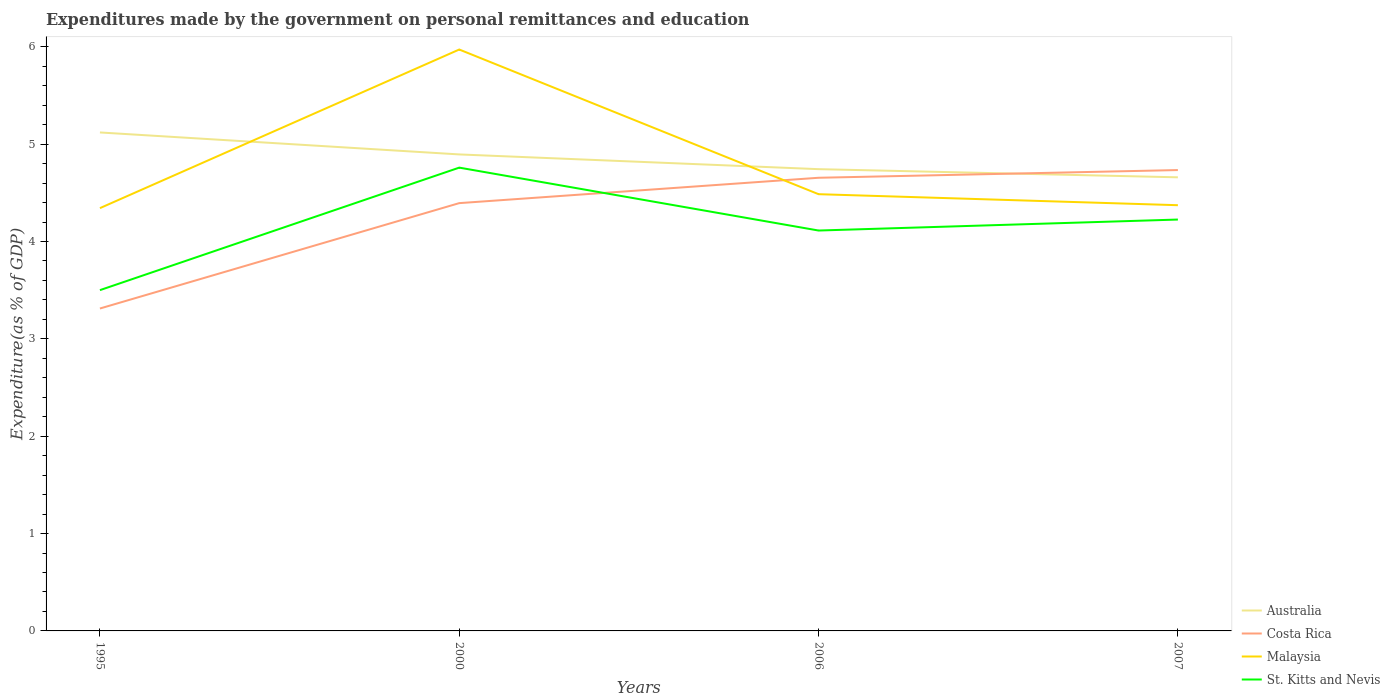Across all years, what is the maximum expenditures made by the government on personal remittances and education in St. Kitts and Nevis?
Keep it short and to the point. 3.5. What is the total expenditures made by the government on personal remittances and education in Australia in the graph?
Make the answer very short. 0.24. What is the difference between the highest and the second highest expenditures made by the government on personal remittances and education in Costa Rica?
Give a very brief answer. 1.42. How many lines are there?
Offer a terse response. 4. How many years are there in the graph?
Make the answer very short. 4. Are the values on the major ticks of Y-axis written in scientific E-notation?
Provide a short and direct response. No. Does the graph contain any zero values?
Provide a succinct answer. No. Does the graph contain grids?
Provide a short and direct response. No. How are the legend labels stacked?
Ensure brevity in your answer.  Vertical. What is the title of the graph?
Your answer should be compact. Expenditures made by the government on personal remittances and education. Does "Bahamas" appear as one of the legend labels in the graph?
Your answer should be compact. No. What is the label or title of the X-axis?
Your answer should be very brief. Years. What is the label or title of the Y-axis?
Make the answer very short. Expenditure(as % of GDP). What is the Expenditure(as % of GDP) of Australia in 1995?
Keep it short and to the point. 5.12. What is the Expenditure(as % of GDP) in Costa Rica in 1995?
Offer a terse response. 3.31. What is the Expenditure(as % of GDP) in Malaysia in 1995?
Offer a very short reply. 4.34. What is the Expenditure(as % of GDP) in St. Kitts and Nevis in 1995?
Keep it short and to the point. 3.5. What is the Expenditure(as % of GDP) of Australia in 2000?
Ensure brevity in your answer.  4.89. What is the Expenditure(as % of GDP) of Costa Rica in 2000?
Provide a short and direct response. 4.39. What is the Expenditure(as % of GDP) of Malaysia in 2000?
Make the answer very short. 5.97. What is the Expenditure(as % of GDP) in St. Kitts and Nevis in 2000?
Your answer should be compact. 4.76. What is the Expenditure(as % of GDP) in Australia in 2006?
Keep it short and to the point. 4.74. What is the Expenditure(as % of GDP) of Costa Rica in 2006?
Provide a succinct answer. 4.65. What is the Expenditure(as % of GDP) in Malaysia in 2006?
Your response must be concise. 4.49. What is the Expenditure(as % of GDP) in St. Kitts and Nevis in 2006?
Provide a short and direct response. 4.11. What is the Expenditure(as % of GDP) of Australia in 2007?
Your response must be concise. 4.66. What is the Expenditure(as % of GDP) of Costa Rica in 2007?
Your answer should be compact. 4.73. What is the Expenditure(as % of GDP) in Malaysia in 2007?
Provide a succinct answer. 4.37. What is the Expenditure(as % of GDP) of St. Kitts and Nevis in 2007?
Offer a terse response. 4.23. Across all years, what is the maximum Expenditure(as % of GDP) in Australia?
Your response must be concise. 5.12. Across all years, what is the maximum Expenditure(as % of GDP) of Costa Rica?
Your answer should be compact. 4.73. Across all years, what is the maximum Expenditure(as % of GDP) in Malaysia?
Make the answer very short. 5.97. Across all years, what is the maximum Expenditure(as % of GDP) in St. Kitts and Nevis?
Your answer should be very brief. 4.76. Across all years, what is the minimum Expenditure(as % of GDP) in Australia?
Provide a succinct answer. 4.66. Across all years, what is the minimum Expenditure(as % of GDP) of Costa Rica?
Your answer should be very brief. 3.31. Across all years, what is the minimum Expenditure(as % of GDP) in Malaysia?
Your response must be concise. 4.34. Across all years, what is the minimum Expenditure(as % of GDP) of St. Kitts and Nevis?
Your answer should be very brief. 3.5. What is the total Expenditure(as % of GDP) in Australia in the graph?
Your answer should be compact. 19.42. What is the total Expenditure(as % of GDP) of Costa Rica in the graph?
Make the answer very short. 17.09. What is the total Expenditure(as % of GDP) of Malaysia in the graph?
Ensure brevity in your answer.  19.17. What is the total Expenditure(as % of GDP) of St. Kitts and Nevis in the graph?
Ensure brevity in your answer.  16.6. What is the difference between the Expenditure(as % of GDP) in Australia in 1995 and that in 2000?
Offer a very short reply. 0.23. What is the difference between the Expenditure(as % of GDP) of Costa Rica in 1995 and that in 2000?
Give a very brief answer. -1.08. What is the difference between the Expenditure(as % of GDP) in Malaysia in 1995 and that in 2000?
Ensure brevity in your answer.  -1.63. What is the difference between the Expenditure(as % of GDP) in St. Kitts and Nevis in 1995 and that in 2000?
Ensure brevity in your answer.  -1.26. What is the difference between the Expenditure(as % of GDP) in Australia in 1995 and that in 2006?
Provide a succinct answer. 0.38. What is the difference between the Expenditure(as % of GDP) of Costa Rica in 1995 and that in 2006?
Ensure brevity in your answer.  -1.34. What is the difference between the Expenditure(as % of GDP) in Malaysia in 1995 and that in 2006?
Provide a succinct answer. -0.14. What is the difference between the Expenditure(as % of GDP) in St. Kitts and Nevis in 1995 and that in 2006?
Your response must be concise. -0.61. What is the difference between the Expenditure(as % of GDP) in Australia in 1995 and that in 2007?
Offer a terse response. 0.46. What is the difference between the Expenditure(as % of GDP) in Costa Rica in 1995 and that in 2007?
Offer a very short reply. -1.42. What is the difference between the Expenditure(as % of GDP) in Malaysia in 1995 and that in 2007?
Your response must be concise. -0.03. What is the difference between the Expenditure(as % of GDP) in St. Kitts and Nevis in 1995 and that in 2007?
Keep it short and to the point. -0.72. What is the difference between the Expenditure(as % of GDP) in Australia in 2000 and that in 2006?
Provide a succinct answer. 0.15. What is the difference between the Expenditure(as % of GDP) of Costa Rica in 2000 and that in 2006?
Give a very brief answer. -0.26. What is the difference between the Expenditure(as % of GDP) of Malaysia in 2000 and that in 2006?
Offer a terse response. 1.49. What is the difference between the Expenditure(as % of GDP) of St. Kitts and Nevis in 2000 and that in 2006?
Your answer should be very brief. 0.65. What is the difference between the Expenditure(as % of GDP) of Australia in 2000 and that in 2007?
Ensure brevity in your answer.  0.24. What is the difference between the Expenditure(as % of GDP) of Costa Rica in 2000 and that in 2007?
Make the answer very short. -0.34. What is the difference between the Expenditure(as % of GDP) in Malaysia in 2000 and that in 2007?
Offer a terse response. 1.6. What is the difference between the Expenditure(as % of GDP) of St. Kitts and Nevis in 2000 and that in 2007?
Ensure brevity in your answer.  0.53. What is the difference between the Expenditure(as % of GDP) of Australia in 2006 and that in 2007?
Provide a succinct answer. 0.08. What is the difference between the Expenditure(as % of GDP) in Costa Rica in 2006 and that in 2007?
Make the answer very short. -0.08. What is the difference between the Expenditure(as % of GDP) of Malaysia in 2006 and that in 2007?
Your answer should be very brief. 0.11. What is the difference between the Expenditure(as % of GDP) in St. Kitts and Nevis in 2006 and that in 2007?
Ensure brevity in your answer.  -0.11. What is the difference between the Expenditure(as % of GDP) in Australia in 1995 and the Expenditure(as % of GDP) in Costa Rica in 2000?
Your answer should be compact. 0.73. What is the difference between the Expenditure(as % of GDP) in Australia in 1995 and the Expenditure(as % of GDP) in Malaysia in 2000?
Keep it short and to the point. -0.85. What is the difference between the Expenditure(as % of GDP) in Australia in 1995 and the Expenditure(as % of GDP) in St. Kitts and Nevis in 2000?
Offer a terse response. 0.36. What is the difference between the Expenditure(as % of GDP) of Costa Rica in 1995 and the Expenditure(as % of GDP) of Malaysia in 2000?
Offer a terse response. -2.66. What is the difference between the Expenditure(as % of GDP) in Costa Rica in 1995 and the Expenditure(as % of GDP) in St. Kitts and Nevis in 2000?
Provide a succinct answer. -1.45. What is the difference between the Expenditure(as % of GDP) of Malaysia in 1995 and the Expenditure(as % of GDP) of St. Kitts and Nevis in 2000?
Your answer should be very brief. -0.42. What is the difference between the Expenditure(as % of GDP) of Australia in 1995 and the Expenditure(as % of GDP) of Costa Rica in 2006?
Your answer should be compact. 0.47. What is the difference between the Expenditure(as % of GDP) of Australia in 1995 and the Expenditure(as % of GDP) of Malaysia in 2006?
Provide a short and direct response. 0.63. What is the difference between the Expenditure(as % of GDP) in Australia in 1995 and the Expenditure(as % of GDP) in St. Kitts and Nevis in 2006?
Give a very brief answer. 1.01. What is the difference between the Expenditure(as % of GDP) of Costa Rica in 1995 and the Expenditure(as % of GDP) of Malaysia in 2006?
Your response must be concise. -1.17. What is the difference between the Expenditure(as % of GDP) of Costa Rica in 1995 and the Expenditure(as % of GDP) of St. Kitts and Nevis in 2006?
Give a very brief answer. -0.8. What is the difference between the Expenditure(as % of GDP) in Malaysia in 1995 and the Expenditure(as % of GDP) in St. Kitts and Nevis in 2006?
Provide a succinct answer. 0.23. What is the difference between the Expenditure(as % of GDP) of Australia in 1995 and the Expenditure(as % of GDP) of Costa Rica in 2007?
Provide a short and direct response. 0.39. What is the difference between the Expenditure(as % of GDP) of Australia in 1995 and the Expenditure(as % of GDP) of Malaysia in 2007?
Offer a terse response. 0.75. What is the difference between the Expenditure(as % of GDP) of Australia in 1995 and the Expenditure(as % of GDP) of St. Kitts and Nevis in 2007?
Offer a terse response. 0.89. What is the difference between the Expenditure(as % of GDP) of Costa Rica in 1995 and the Expenditure(as % of GDP) of Malaysia in 2007?
Make the answer very short. -1.06. What is the difference between the Expenditure(as % of GDP) of Costa Rica in 1995 and the Expenditure(as % of GDP) of St. Kitts and Nevis in 2007?
Make the answer very short. -0.91. What is the difference between the Expenditure(as % of GDP) in Malaysia in 1995 and the Expenditure(as % of GDP) in St. Kitts and Nevis in 2007?
Give a very brief answer. 0.12. What is the difference between the Expenditure(as % of GDP) of Australia in 2000 and the Expenditure(as % of GDP) of Costa Rica in 2006?
Your response must be concise. 0.24. What is the difference between the Expenditure(as % of GDP) in Australia in 2000 and the Expenditure(as % of GDP) in Malaysia in 2006?
Offer a very short reply. 0.41. What is the difference between the Expenditure(as % of GDP) in Australia in 2000 and the Expenditure(as % of GDP) in St. Kitts and Nevis in 2006?
Make the answer very short. 0.78. What is the difference between the Expenditure(as % of GDP) of Costa Rica in 2000 and the Expenditure(as % of GDP) of Malaysia in 2006?
Offer a terse response. -0.09. What is the difference between the Expenditure(as % of GDP) in Costa Rica in 2000 and the Expenditure(as % of GDP) in St. Kitts and Nevis in 2006?
Keep it short and to the point. 0.28. What is the difference between the Expenditure(as % of GDP) in Malaysia in 2000 and the Expenditure(as % of GDP) in St. Kitts and Nevis in 2006?
Ensure brevity in your answer.  1.86. What is the difference between the Expenditure(as % of GDP) of Australia in 2000 and the Expenditure(as % of GDP) of Costa Rica in 2007?
Keep it short and to the point. 0.16. What is the difference between the Expenditure(as % of GDP) of Australia in 2000 and the Expenditure(as % of GDP) of Malaysia in 2007?
Provide a short and direct response. 0.52. What is the difference between the Expenditure(as % of GDP) of Australia in 2000 and the Expenditure(as % of GDP) of St. Kitts and Nevis in 2007?
Give a very brief answer. 0.67. What is the difference between the Expenditure(as % of GDP) in Costa Rica in 2000 and the Expenditure(as % of GDP) in Malaysia in 2007?
Offer a terse response. 0.02. What is the difference between the Expenditure(as % of GDP) in Costa Rica in 2000 and the Expenditure(as % of GDP) in St. Kitts and Nevis in 2007?
Make the answer very short. 0.17. What is the difference between the Expenditure(as % of GDP) in Malaysia in 2000 and the Expenditure(as % of GDP) in St. Kitts and Nevis in 2007?
Provide a succinct answer. 1.75. What is the difference between the Expenditure(as % of GDP) in Australia in 2006 and the Expenditure(as % of GDP) in Costa Rica in 2007?
Give a very brief answer. 0.01. What is the difference between the Expenditure(as % of GDP) of Australia in 2006 and the Expenditure(as % of GDP) of Malaysia in 2007?
Give a very brief answer. 0.37. What is the difference between the Expenditure(as % of GDP) in Australia in 2006 and the Expenditure(as % of GDP) in St. Kitts and Nevis in 2007?
Give a very brief answer. 0.52. What is the difference between the Expenditure(as % of GDP) of Costa Rica in 2006 and the Expenditure(as % of GDP) of Malaysia in 2007?
Offer a very short reply. 0.28. What is the difference between the Expenditure(as % of GDP) in Costa Rica in 2006 and the Expenditure(as % of GDP) in St. Kitts and Nevis in 2007?
Provide a short and direct response. 0.43. What is the difference between the Expenditure(as % of GDP) of Malaysia in 2006 and the Expenditure(as % of GDP) of St. Kitts and Nevis in 2007?
Keep it short and to the point. 0.26. What is the average Expenditure(as % of GDP) in Australia per year?
Your response must be concise. 4.85. What is the average Expenditure(as % of GDP) of Costa Rica per year?
Offer a very short reply. 4.27. What is the average Expenditure(as % of GDP) of Malaysia per year?
Offer a very short reply. 4.79. What is the average Expenditure(as % of GDP) of St. Kitts and Nevis per year?
Provide a succinct answer. 4.15. In the year 1995, what is the difference between the Expenditure(as % of GDP) in Australia and Expenditure(as % of GDP) in Costa Rica?
Offer a very short reply. 1.81. In the year 1995, what is the difference between the Expenditure(as % of GDP) in Australia and Expenditure(as % of GDP) in Malaysia?
Provide a succinct answer. 0.78. In the year 1995, what is the difference between the Expenditure(as % of GDP) of Australia and Expenditure(as % of GDP) of St. Kitts and Nevis?
Keep it short and to the point. 1.62. In the year 1995, what is the difference between the Expenditure(as % of GDP) of Costa Rica and Expenditure(as % of GDP) of Malaysia?
Keep it short and to the point. -1.03. In the year 1995, what is the difference between the Expenditure(as % of GDP) of Costa Rica and Expenditure(as % of GDP) of St. Kitts and Nevis?
Your response must be concise. -0.19. In the year 1995, what is the difference between the Expenditure(as % of GDP) of Malaysia and Expenditure(as % of GDP) of St. Kitts and Nevis?
Keep it short and to the point. 0.84. In the year 2000, what is the difference between the Expenditure(as % of GDP) in Australia and Expenditure(as % of GDP) in Costa Rica?
Ensure brevity in your answer.  0.5. In the year 2000, what is the difference between the Expenditure(as % of GDP) in Australia and Expenditure(as % of GDP) in Malaysia?
Your answer should be very brief. -1.08. In the year 2000, what is the difference between the Expenditure(as % of GDP) in Australia and Expenditure(as % of GDP) in St. Kitts and Nevis?
Your answer should be very brief. 0.14. In the year 2000, what is the difference between the Expenditure(as % of GDP) in Costa Rica and Expenditure(as % of GDP) in Malaysia?
Provide a succinct answer. -1.58. In the year 2000, what is the difference between the Expenditure(as % of GDP) of Costa Rica and Expenditure(as % of GDP) of St. Kitts and Nevis?
Offer a very short reply. -0.36. In the year 2000, what is the difference between the Expenditure(as % of GDP) in Malaysia and Expenditure(as % of GDP) in St. Kitts and Nevis?
Provide a succinct answer. 1.21. In the year 2006, what is the difference between the Expenditure(as % of GDP) in Australia and Expenditure(as % of GDP) in Costa Rica?
Keep it short and to the point. 0.09. In the year 2006, what is the difference between the Expenditure(as % of GDP) of Australia and Expenditure(as % of GDP) of Malaysia?
Provide a succinct answer. 0.26. In the year 2006, what is the difference between the Expenditure(as % of GDP) in Australia and Expenditure(as % of GDP) in St. Kitts and Nevis?
Give a very brief answer. 0.63. In the year 2006, what is the difference between the Expenditure(as % of GDP) in Costa Rica and Expenditure(as % of GDP) in Malaysia?
Your response must be concise. 0.17. In the year 2006, what is the difference between the Expenditure(as % of GDP) in Costa Rica and Expenditure(as % of GDP) in St. Kitts and Nevis?
Your answer should be compact. 0.54. In the year 2006, what is the difference between the Expenditure(as % of GDP) in Malaysia and Expenditure(as % of GDP) in St. Kitts and Nevis?
Offer a terse response. 0.37. In the year 2007, what is the difference between the Expenditure(as % of GDP) of Australia and Expenditure(as % of GDP) of Costa Rica?
Your answer should be very brief. -0.07. In the year 2007, what is the difference between the Expenditure(as % of GDP) in Australia and Expenditure(as % of GDP) in Malaysia?
Provide a short and direct response. 0.29. In the year 2007, what is the difference between the Expenditure(as % of GDP) of Australia and Expenditure(as % of GDP) of St. Kitts and Nevis?
Provide a short and direct response. 0.43. In the year 2007, what is the difference between the Expenditure(as % of GDP) in Costa Rica and Expenditure(as % of GDP) in Malaysia?
Your response must be concise. 0.36. In the year 2007, what is the difference between the Expenditure(as % of GDP) of Costa Rica and Expenditure(as % of GDP) of St. Kitts and Nevis?
Make the answer very short. 0.51. In the year 2007, what is the difference between the Expenditure(as % of GDP) in Malaysia and Expenditure(as % of GDP) in St. Kitts and Nevis?
Your answer should be compact. 0.15. What is the ratio of the Expenditure(as % of GDP) in Australia in 1995 to that in 2000?
Ensure brevity in your answer.  1.05. What is the ratio of the Expenditure(as % of GDP) in Costa Rica in 1995 to that in 2000?
Provide a short and direct response. 0.75. What is the ratio of the Expenditure(as % of GDP) of Malaysia in 1995 to that in 2000?
Give a very brief answer. 0.73. What is the ratio of the Expenditure(as % of GDP) of St. Kitts and Nevis in 1995 to that in 2000?
Give a very brief answer. 0.74. What is the ratio of the Expenditure(as % of GDP) of Australia in 1995 to that in 2006?
Give a very brief answer. 1.08. What is the ratio of the Expenditure(as % of GDP) in Costa Rica in 1995 to that in 2006?
Offer a terse response. 0.71. What is the ratio of the Expenditure(as % of GDP) of Malaysia in 1995 to that in 2006?
Your answer should be very brief. 0.97. What is the ratio of the Expenditure(as % of GDP) of St. Kitts and Nevis in 1995 to that in 2006?
Give a very brief answer. 0.85. What is the ratio of the Expenditure(as % of GDP) of Australia in 1995 to that in 2007?
Ensure brevity in your answer.  1.1. What is the ratio of the Expenditure(as % of GDP) of Costa Rica in 1995 to that in 2007?
Your answer should be compact. 0.7. What is the ratio of the Expenditure(as % of GDP) in St. Kitts and Nevis in 1995 to that in 2007?
Offer a very short reply. 0.83. What is the ratio of the Expenditure(as % of GDP) in Australia in 2000 to that in 2006?
Your answer should be very brief. 1.03. What is the ratio of the Expenditure(as % of GDP) in Costa Rica in 2000 to that in 2006?
Make the answer very short. 0.94. What is the ratio of the Expenditure(as % of GDP) of Malaysia in 2000 to that in 2006?
Ensure brevity in your answer.  1.33. What is the ratio of the Expenditure(as % of GDP) in St. Kitts and Nevis in 2000 to that in 2006?
Provide a short and direct response. 1.16. What is the ratio of the Expenditure(as % of GDP) of Australia in 2000 to that in 2007?
Give a very brief answer. 1.05. What is the ratio of the Expenditure(as % of GDP) of Costa Rica in 2000 to that in 2007?
Your answer should be compact. 0.93. What is the ratio of the Expenditure(as % of GDP) of Malaysia in 2000 to that in 2007?
Provide a short and direct response. 1.37. What is the ratio of the Expenditure(as % of GDP) of St. Kitts and Nevis in 2000 to that in 2007?
Your answer should be compact. 1.13. What is the ratio of the Expenditure(as % of GDP) in Costa Rica in 2006 to that in 2007?
Your answer should be compact. 0.98. What is the ratio of the Expenditure(as % of GDP) of Malaysia in 2006 to that in 2007?
Your response must be concise. 1.03. What is the ratio of the Expenditure(as % of GDP) of St. Kitts and Nevis in 2006 to that in 2007?
Offer a very short reply. 0.97. What is the difference between the highest and the second highest Expenditure(as % of GDP) of Australia?
Provide a short and direct response. 0.23. What is the difference between the highest and the second highest Expenditure(as % of GDP) of Costa Rica?
Provide a short and direct response. 0.08. What is the difference between the highest and the second highest Expenditure(as % of GDP) of Malaysia?
Provide a succinct answer. 1.49. What is the difference between the highest and the second highest Expenditure(as % of GDP) of St. Kitts and Nevis?
Keep it short and to the point. 0.53. What is the difference between the highest and the lowest Expenditure(as % of GDP) of Australia?
Make the answer very short. 0.46. What is the difference between the highest and the lowest Expenditure(as % of GDP) of Costa Rica?
Give a very brief answer. 1.42. What is the difference between the highest and the lowest Expenditure(as % of GDP) in Malaysia?
Your answer should be compact. 1.63. What is the difference between the highest and the lowest Expenditure(as % of GDP) in St. Kitts and Nevis?
Your answer should be compact. 1.26. 